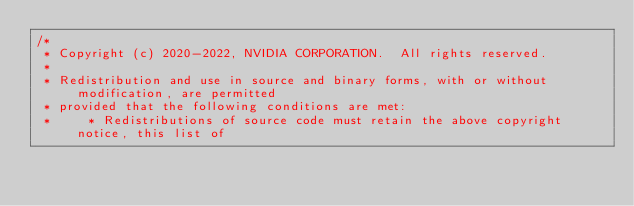<code> <loc_0><loc_0><loc_500><loc_500><_Cuda_>/*
 * Copyright (c) 2020-2022, NVIDIA CORPORATION.  All rights reserved.
 * 
 * Redistribution and use in source and binary forms, with or without modification, are permitted
 * provided that the following conditions are met:
 *     * Redistributions of source code must retain the above copyright notice, this list of</code> 